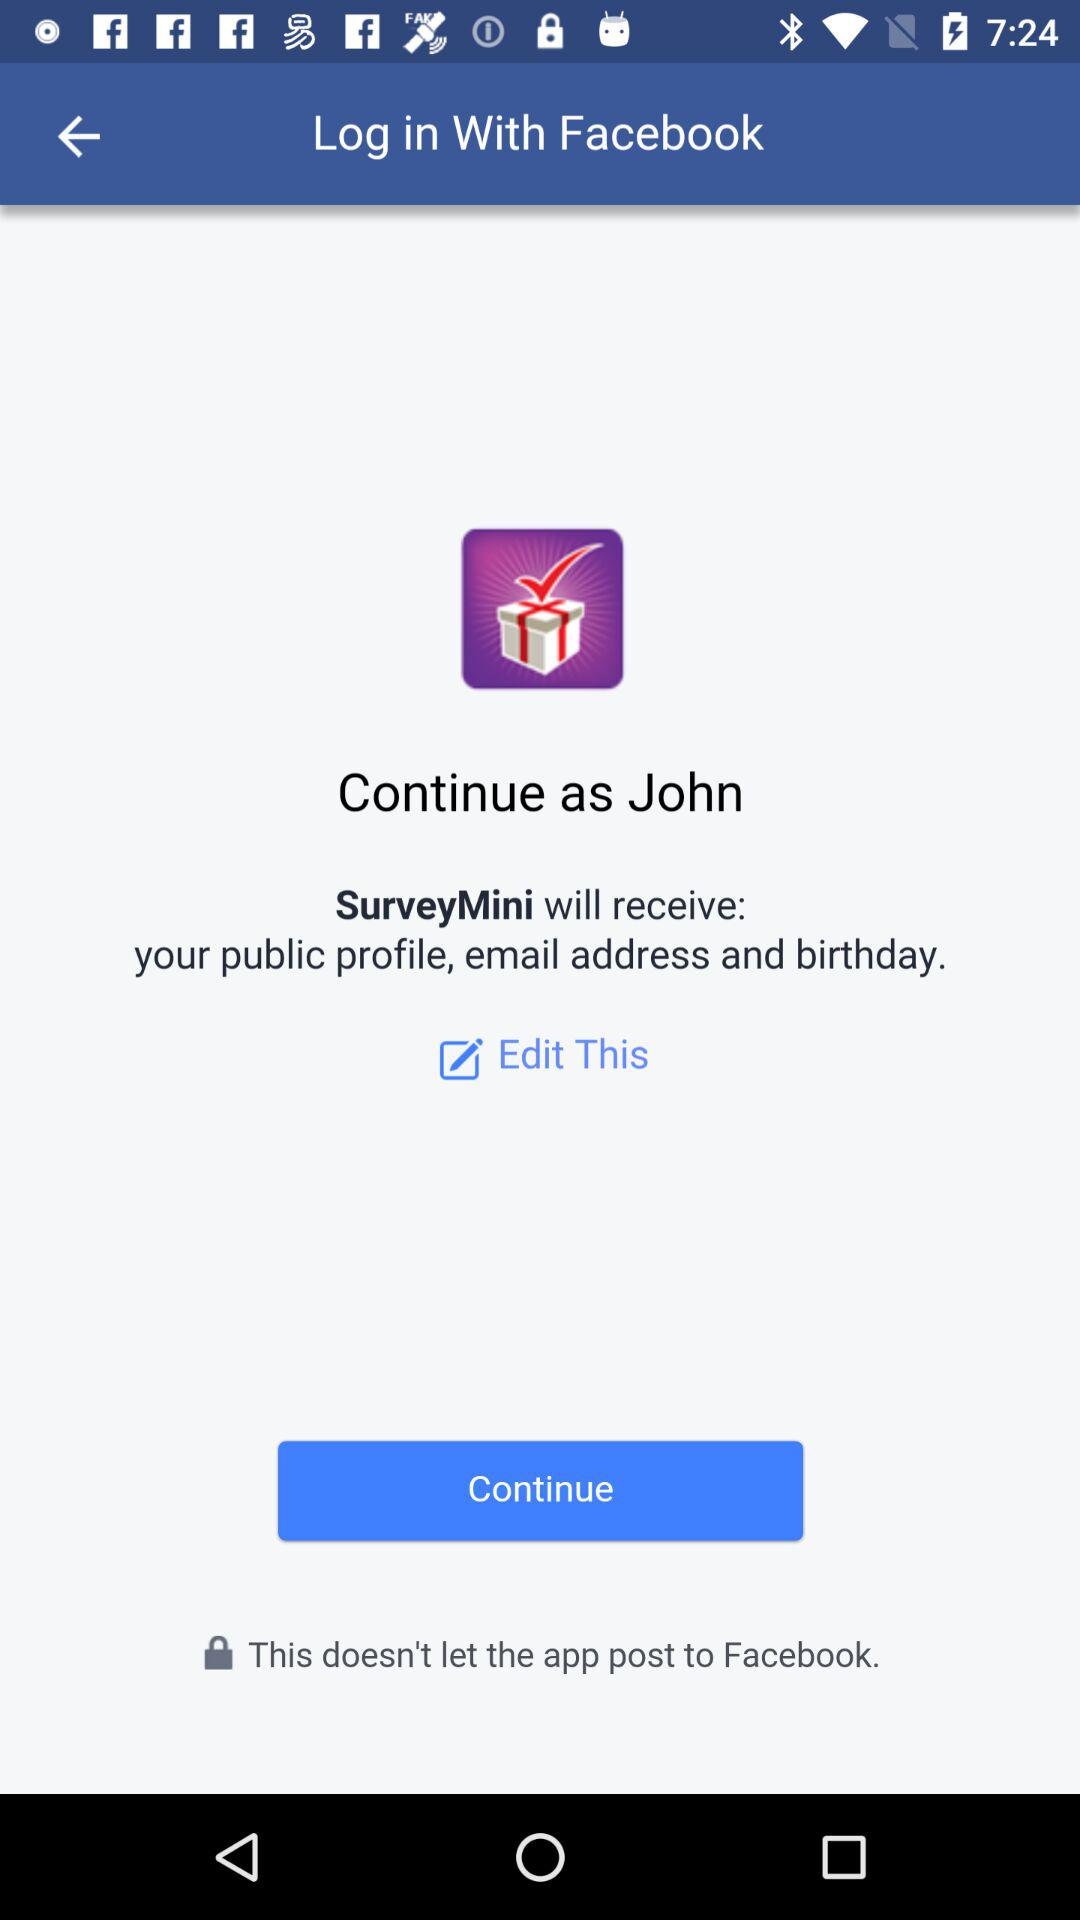What is the name of the user? The user name is "John". 